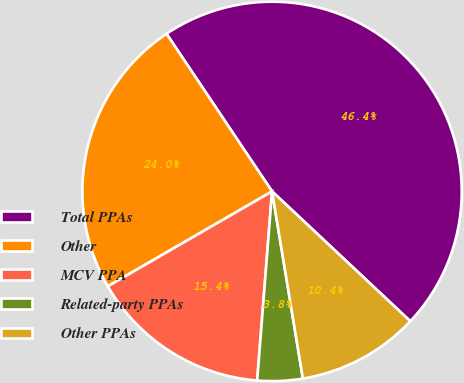<chart> <loc_0><loc_0><loc_500><loc_500><pie_chart><fcel>Total PPAs<fcel>Other<fcel>MCV PPA<fcel>Related-party PPAs<fcel>Other PPAs<nl><fcel>46.39%<fcel>23.95%<fcel>15.41%<fcel>3.85%<fcel>10.4%<nl></chart> 